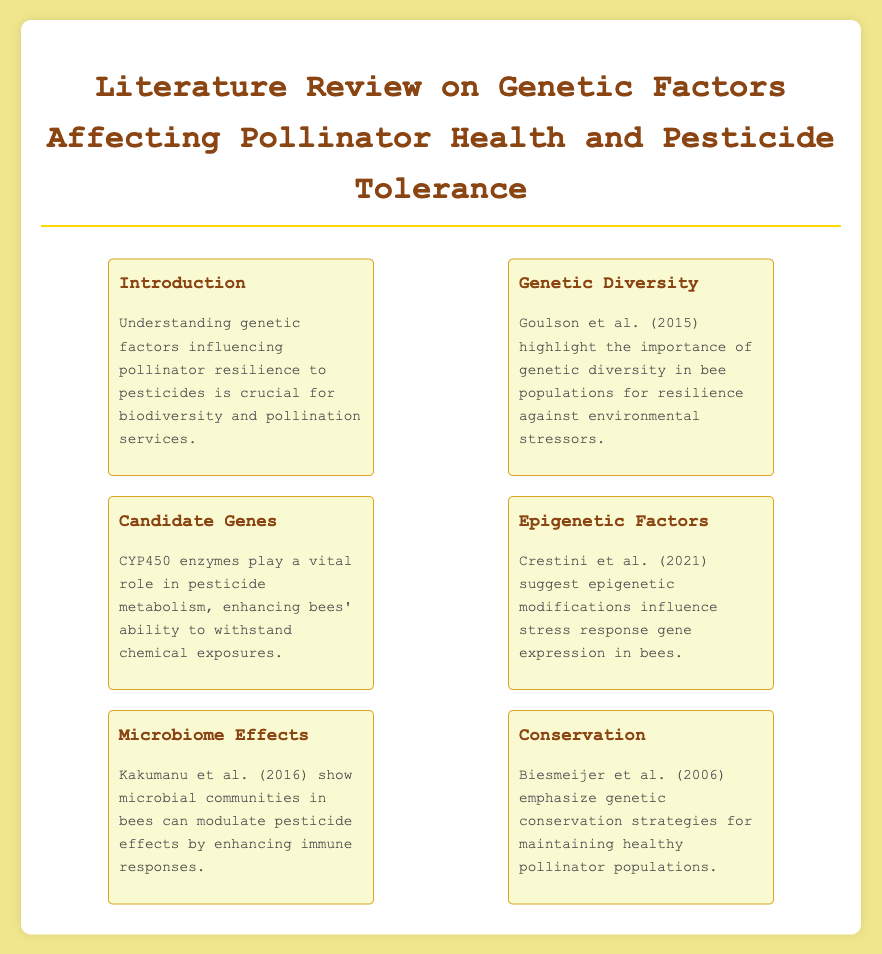What is the title of the document? The title is prominently displayed at the top of the document, which clarifies its content focus.
Answer: Genetic Factors in Bee Pesticide Resistance Who is mentioned as highlighting the importance of genetic diversity? The document references Goulson et al. (2015) in the context of genetic diversity and resilience.
Answer: Goulson et al. (2015) What role do CYP450 enzymes play according to the document? The document states that CYP450 enzymes are significant for pesticide metabolism in bees.
Answer: Pesticide metabolism Which year was the epigenetic factors study published? The reference to Crestini et al. is provided with the year indicating when their findings were published.
Answer: 2021 What is emphasized for maintaining healthy pollinator populations? The document points to genetic conservation strategies as key to safeguarding pollinator health.
Answer: Genetic conservation strategies Which microbial communities are referenced in relation to pesticide effects? Kakumanu et al. (2016) are noted in the context of how microbial communities can aid in modulating pesticide impacts on bees.
Answer: Microbial communities How many menu items are there in the document? The number of distinct sections (menu items) provides a count of the topics covered in the review.
Answer: Six What is the main focus of the introduction section? The introduction outlines the critical nature of understanding genetic factors related to pollinator resilience.
Answer: Genetic factors influencing pollinator resilience What key factor does Biesmeijer et al. (2006) emphasize? The document discusses the essential conservation strategies for pollinators outlined by Biesmeijer et al.
Answer: Conservation strategies 